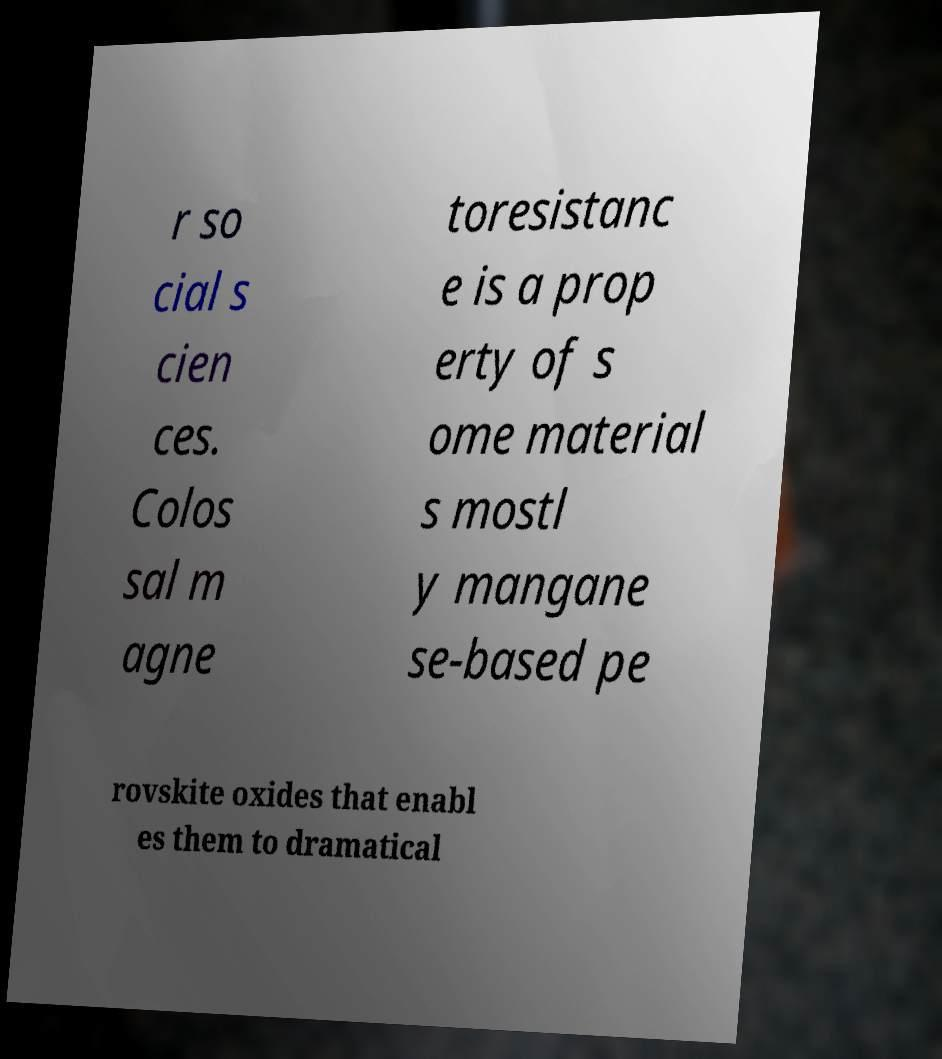For documentation purposes, I need the text within this image transcribed. Could you provide that? r so cial s cien ces. Colos sal m agne toresistanc e is a prop erty of s ome material s mostl y mangane se-based pe rovskite oxides that enabl es them to dramatical 